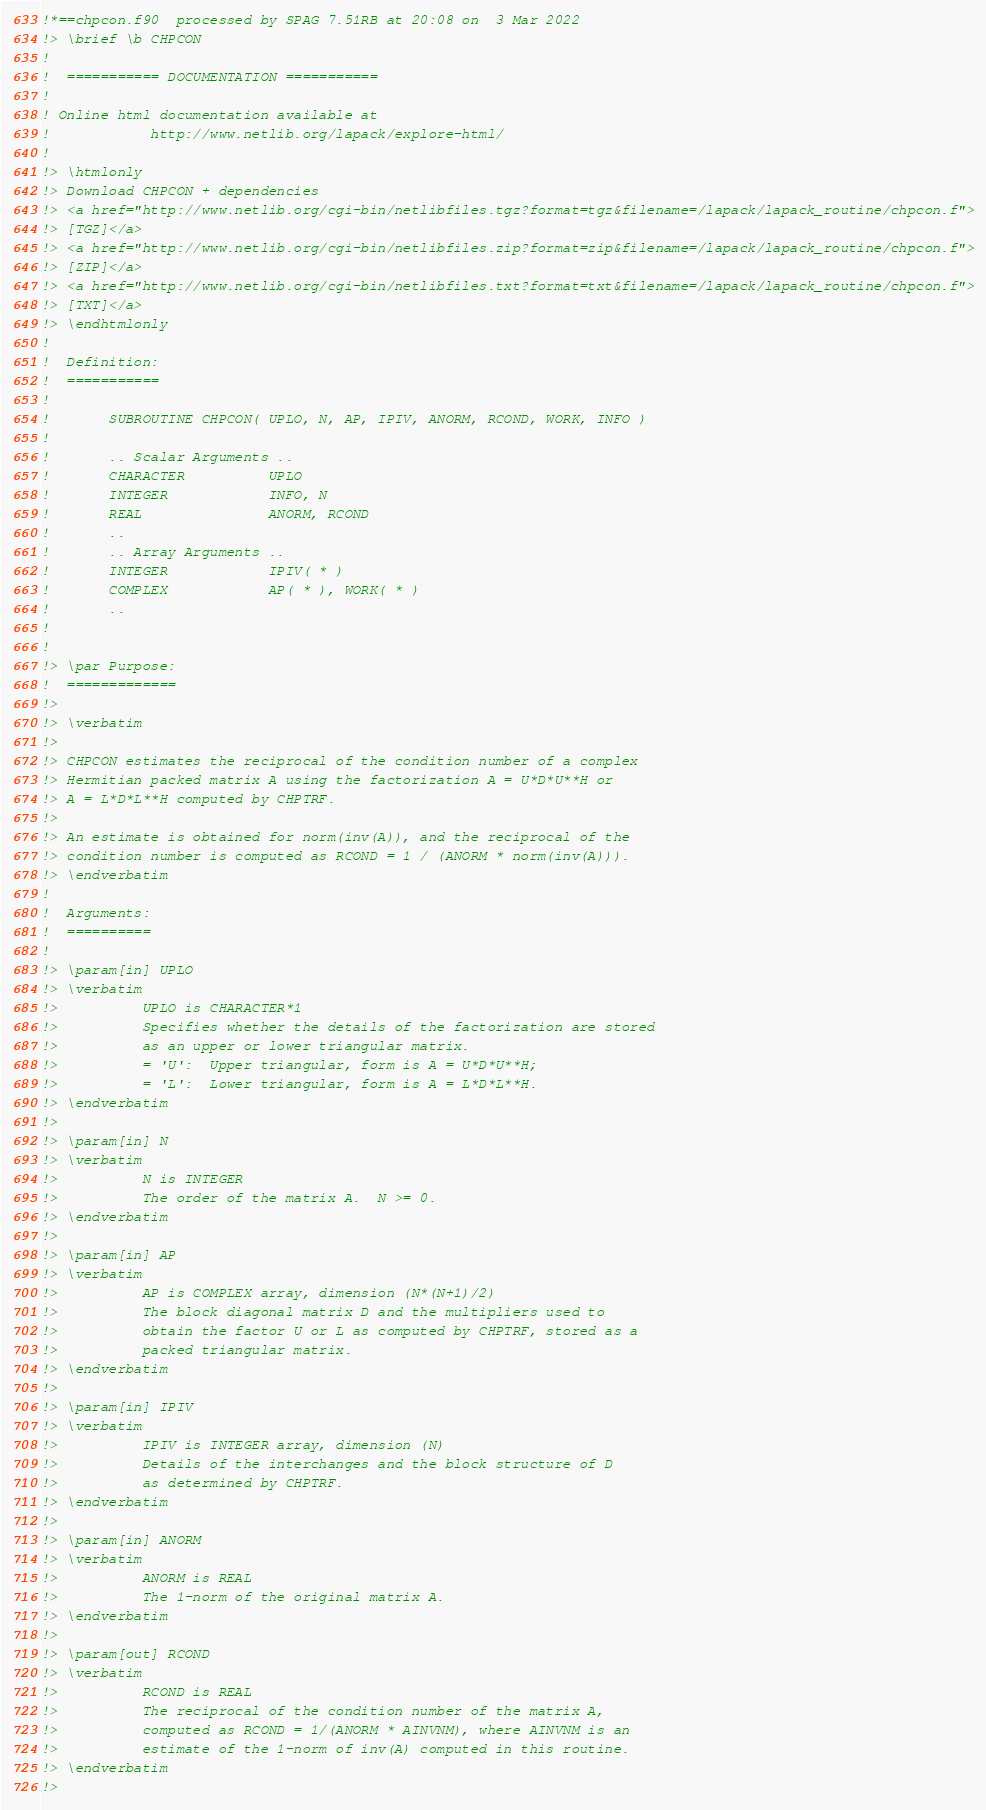<code> <loc_0><loc_0><loc_500><loc_500><_FORTRAN_>!*==chpcon.f90  processed by SPAG 7.51RB at 20:08 on  3 Mar 2022
!> \brief \b CHPCON
!
!  =========== DOCUMENTATION ===========
!
! Online html documentation available at
!            http://www.netlib.org/lapack/explore-html/
!
!> \htmlonly
!> Download CHPCON + dependencies
!> <a href="http://www.netlib.org/cgi-bin/netlibfiles.tgz?format=tgz&filename=/lapack/lapack_routine/chpcon.f">
!> [TGZ]</a>
!> <a href="http://www.netlib.org/cgi-bin/netlibfiles.zip?format=zip&filename=/lapack/lapack_routine/chpcon.f">
!> [ZIP]</a>
!> <a href="http://www.netlib.org/cgi-bin/netlibfiles.txt?format=txt&filename=/lapack/lapack_routine/chpcon.f">
!> [TXT]</a>
!> \endhtmlonly
!
!  Definition:
!  ===========
!
!       SUBROUTINE CHPCON( UPLO, N, AP, IPIV, ANORM, RCOND, WORK, INFO )
!
!       .. Scalar Arguments ..
!       CHARACTER          UPLO
!       INTEGER            INFO, N
!       REAL               ANORM, RCOND
!       ..
!       .. Array Arguments ..
!       INTEGER            IPIV( * )
!       COMPLEX            AP( * ), WORK( * )
!       ..
!
!
!> \par Purpose:
!  =============
!>
!> \verbatim
!>
!> CHPCON estimates the reciprocal of the condition number of a complex
!> Hermitian packed matrix A using the factorization A = U*D*U**H or
!> A = L*D*L**H computed by CHPTRF.
!>
!> An estimate is obtained for norm(inv(A)), and the reciprocal of the
!> condition number is computed as RCOND = 1 / (ANORM * norm(inv(A))).
!> \endverbatim
!
!  Arguments:
!  ==========
!
!> \param[in] UPLO
!> \verbatim
!>          UPLO is CHARACTER*1
!>          Specifies whether the details of the factorization are stored
!>          as an upper or lower triangular matrix.
!>          = 'U':  Upper triangular, form is A = U*D*U**H;
!>          = 'L':  Lower triangular, form is A = L*D*L**H.
!> \endverbatim
!>
!> \param[in] N
!> \verbatim
!>          N is INTEGER
!>          The order of the matrix A.  N >= 0.
!> \endverbatim
!>
!> \param[in] AP
!> \verbatim
!>          AP is COMPLEX array, dimension (N*(N+1)/2)
!>          The block diagonal matrix D and the multipliers used to
!>          obtain the factor U or L as computed by CHPTRF, stored as a
!>          packed triangular matrix.
!> \endverbatim
!>
!> \param[in] IPIV
!> \verbatim
!>          IPIV is INTEGER array, dimension (N)
!>          Details of the interchanges and the block structure of D
!>          as determined by CHPTRF.
!> \endverbatim
!>
!> \param[in] ANORM
!> \verbatim
!>          ANORM is REAL
!>          The 1-norm of the original matrix A.
!> \endverbatim
!>
!> \param[out] RCOND
!> \verbatim
!>          RCOND is REAL
!>          The reciprocal of the condition number of the matrix A,
!>          computed as RCOND = 1/(ANORM * AINVNM), where AINVNM is an
!>          estimate of the 1-norm of inv(A) computed in this routine.
!> \endverbatim
!></code> 